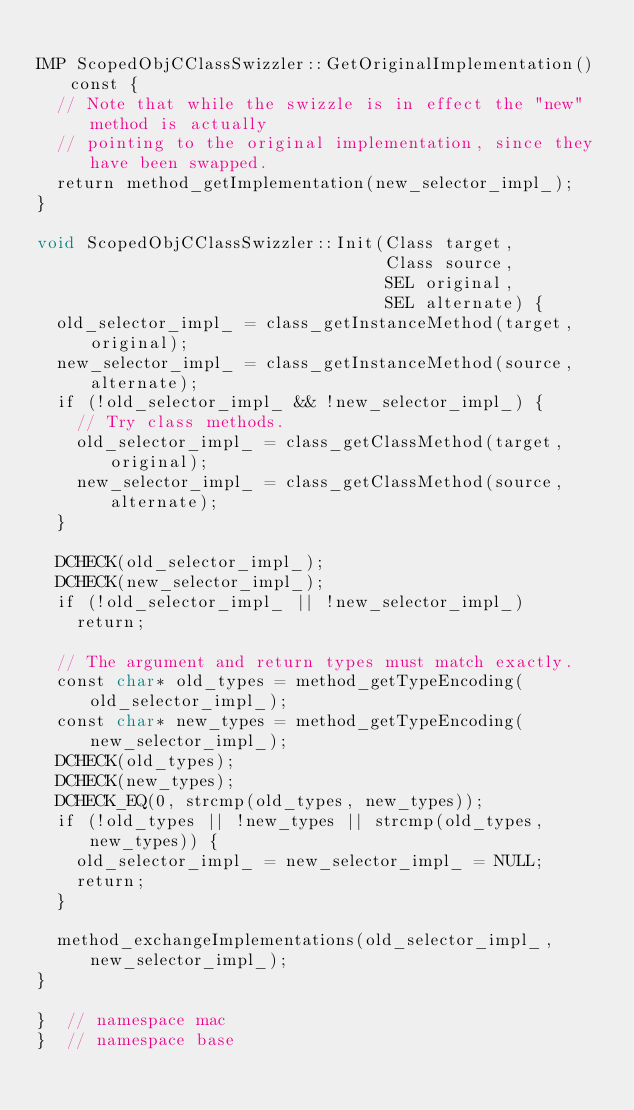Convert code to text. <code><loc_0><loc_0><loc_500><loc_500><_ObjectiveC_>
IMP ScopedObjCClassSwizzler::GetOriginalImplementation() const {
  // Note that while the swizzle is in effect the "new" method is actually
  // pointing to the original implementation, since they have been swapped.
  return method_getImplementation(new_selector_impl_);
}

void ScopedObjCClassSwizzler::Init(Class target,
                                   Class source,
                                   SEL original,
                                   SEL alternate) {
  old_selector_impl_ = class_getInstanceMethod(target, original);
  new_selector_impl_ = class_getInstanceMethod(source, alternate);
  if (!old_selector_impl_ && !new_selector_impl_) {
    // Try class methods.
    old_selector_impl_ = class_getClassMethod(target, original);
    new_selector_impl_ = class_getClassMethod(source, alternate);
  }

  DCHECK(old_selector_impl_);
  DCHECK(new_selector_impl_);
  if (!old_selector_impl_ || !new_selector_impl_)
    return;

  // The argument and return types must match exactly.
  const char* old_types = method_getTypeEncoding(old_selector_impl_);
  const char* new_types = method_getTypeEncoding(new_selector_impl_);
  DCHECK(old_types);
  DCHECK(new_types);
  DCHECK_EQ(0, strcmp(old_types, new_types));
  if (!old_types || !new_types || strcmp(old_types, new_types)) {
    old_selector_impl_ = new_selector_impl_ = NULL;
    return;
  }

  method_exchangeImplementations(old_selector_impl_, new_selector_impl_);
}

}  // namespace mac
}  // namespace base
</code> 